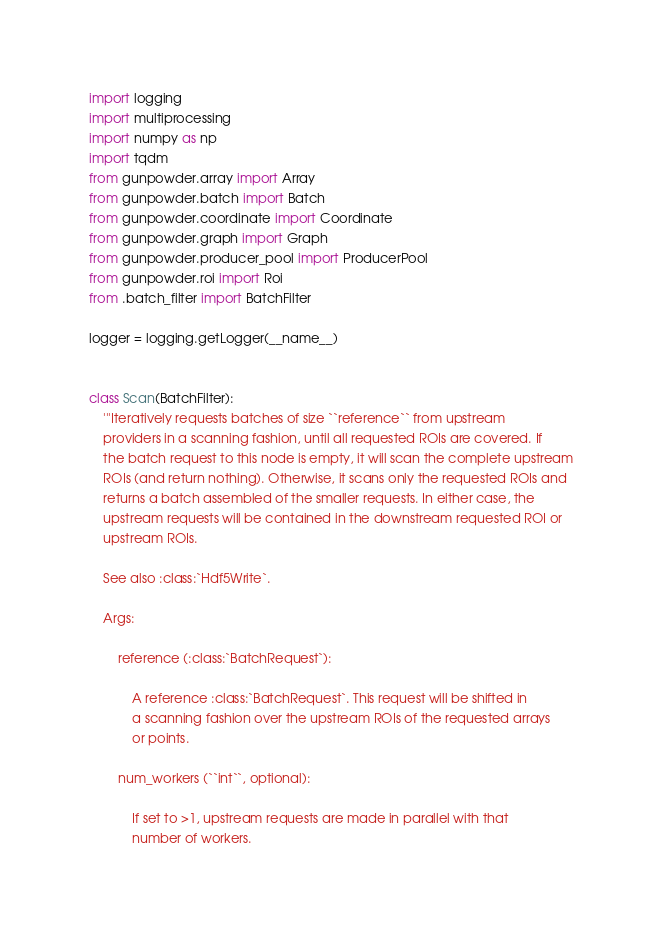Convert code to text. <code><loc_0><loc_0><loc_500><loc_500><_Python_>import logging
import multiprocessing
import numpy as np
import tqdm
from gunpowder.array import Array
from gunpowder.batch import Batch
from gunpowder.coordinate import Coordinate
from gunpowder.graph import Graph
from gunpowder.producer_pool import ProducerPool
from gunpowder.roi import Roi
from .batch_filter import BatchFilter

logger = logging.getLogger(__name__)


class Scan(BatchFilter):
    '''Iteratively requests batches of size ``reference`` from upstream
    providers in a scanning fashion, until all requested ROIs are covered. If
    the batch request to this node is empty, it will scan the complete upstream
    ROIs (and return nothing). Otherwise, it scans only the requested ROIs and
    returns a batch assembled of the smaller requests. In either case, the
    upstream requests will be contained in the downstream requested ROI or
    upstream ROIs.

    See also :class:`Hdf5Write`.

    Args:

        reference (:class:`BatchRequest`):

            A reference :class:`BatchRequest`. This request will be shifted in
            a scanning fashion over the upstream ROIs of the requested arrays
            or points.

        num_workers (``int``, optional):

            If set to >1, upstream requests are made in parallel with that
            number of workers.
</code> 